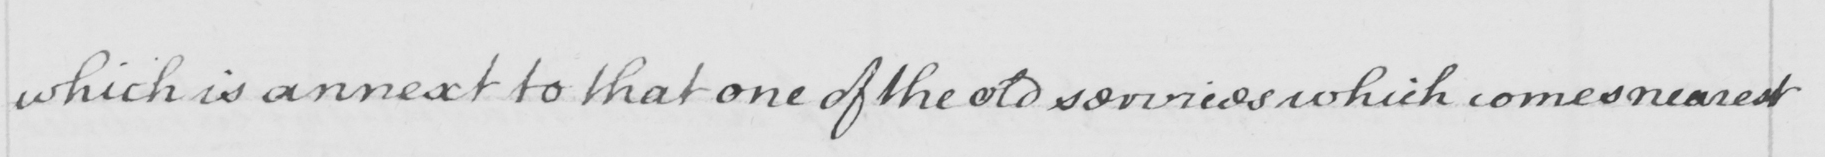Transcribe the text shown in this historical manuscript line. which is annext to that one of the old services which comes nearest 